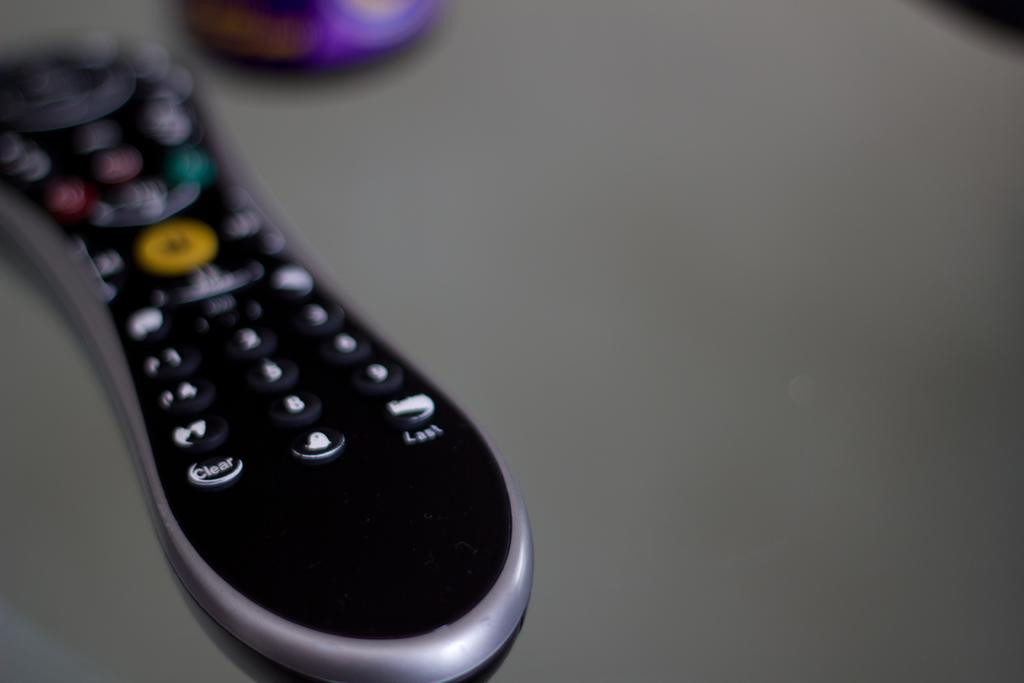<image>
Create a compact narrative representing the image presented. A remote control lies on a table with the "CLEAR" button visible. 